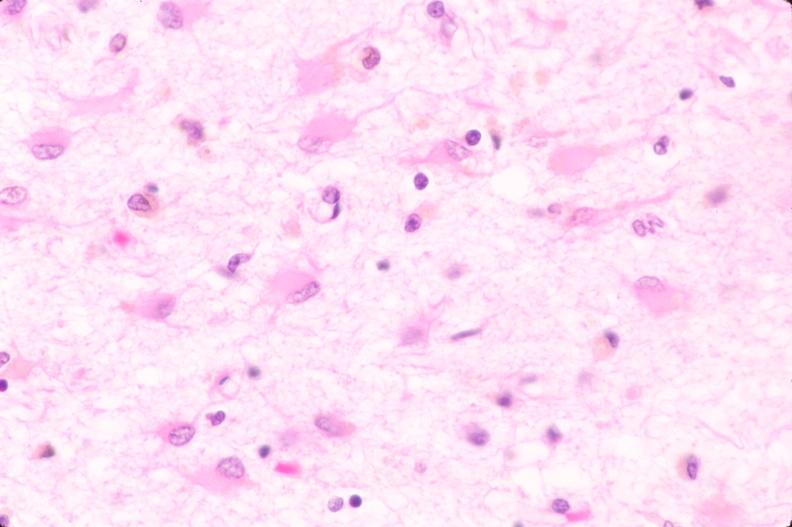what does this image show?
Answer the question using a single word or phrase. Brain 